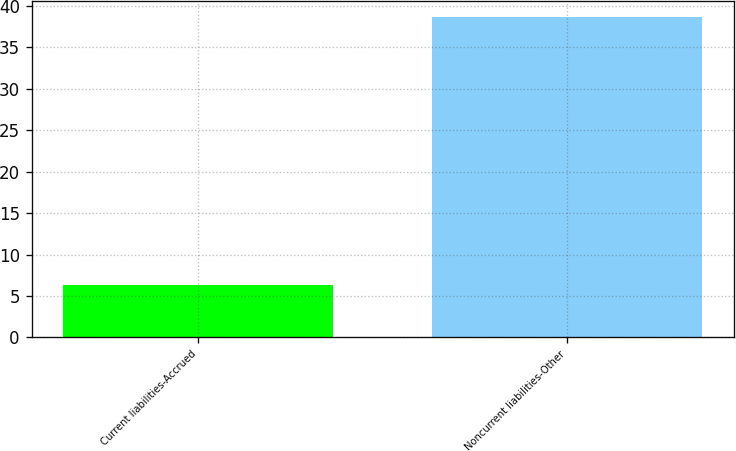Convert chart to OTSL. <chart><loc_0><loc_0><loc_500><loc_500><bar_chart><fcel>Current liabilities-Accrued<fcel>Noncurrent liabilities-Other<nl><fcel>6.3<fcel>38.7<nl></chart> 